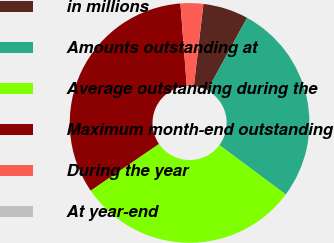Convert chart. <chart><loc_0><loc_0><loc_500><loc_500><pie_chart><fcel>in millions<fcel>Amounts outstanding at<fcel>Average outstanding during the<fcel>Maximum month-end outstanding<fcel>During the year<fcel>At year-end<nl><fcel>6.12%<fcel>27.22%<fcel>30.28%<fcel>33.33%<fcel>3.06%<fcel>0.0%<nl></chart> 